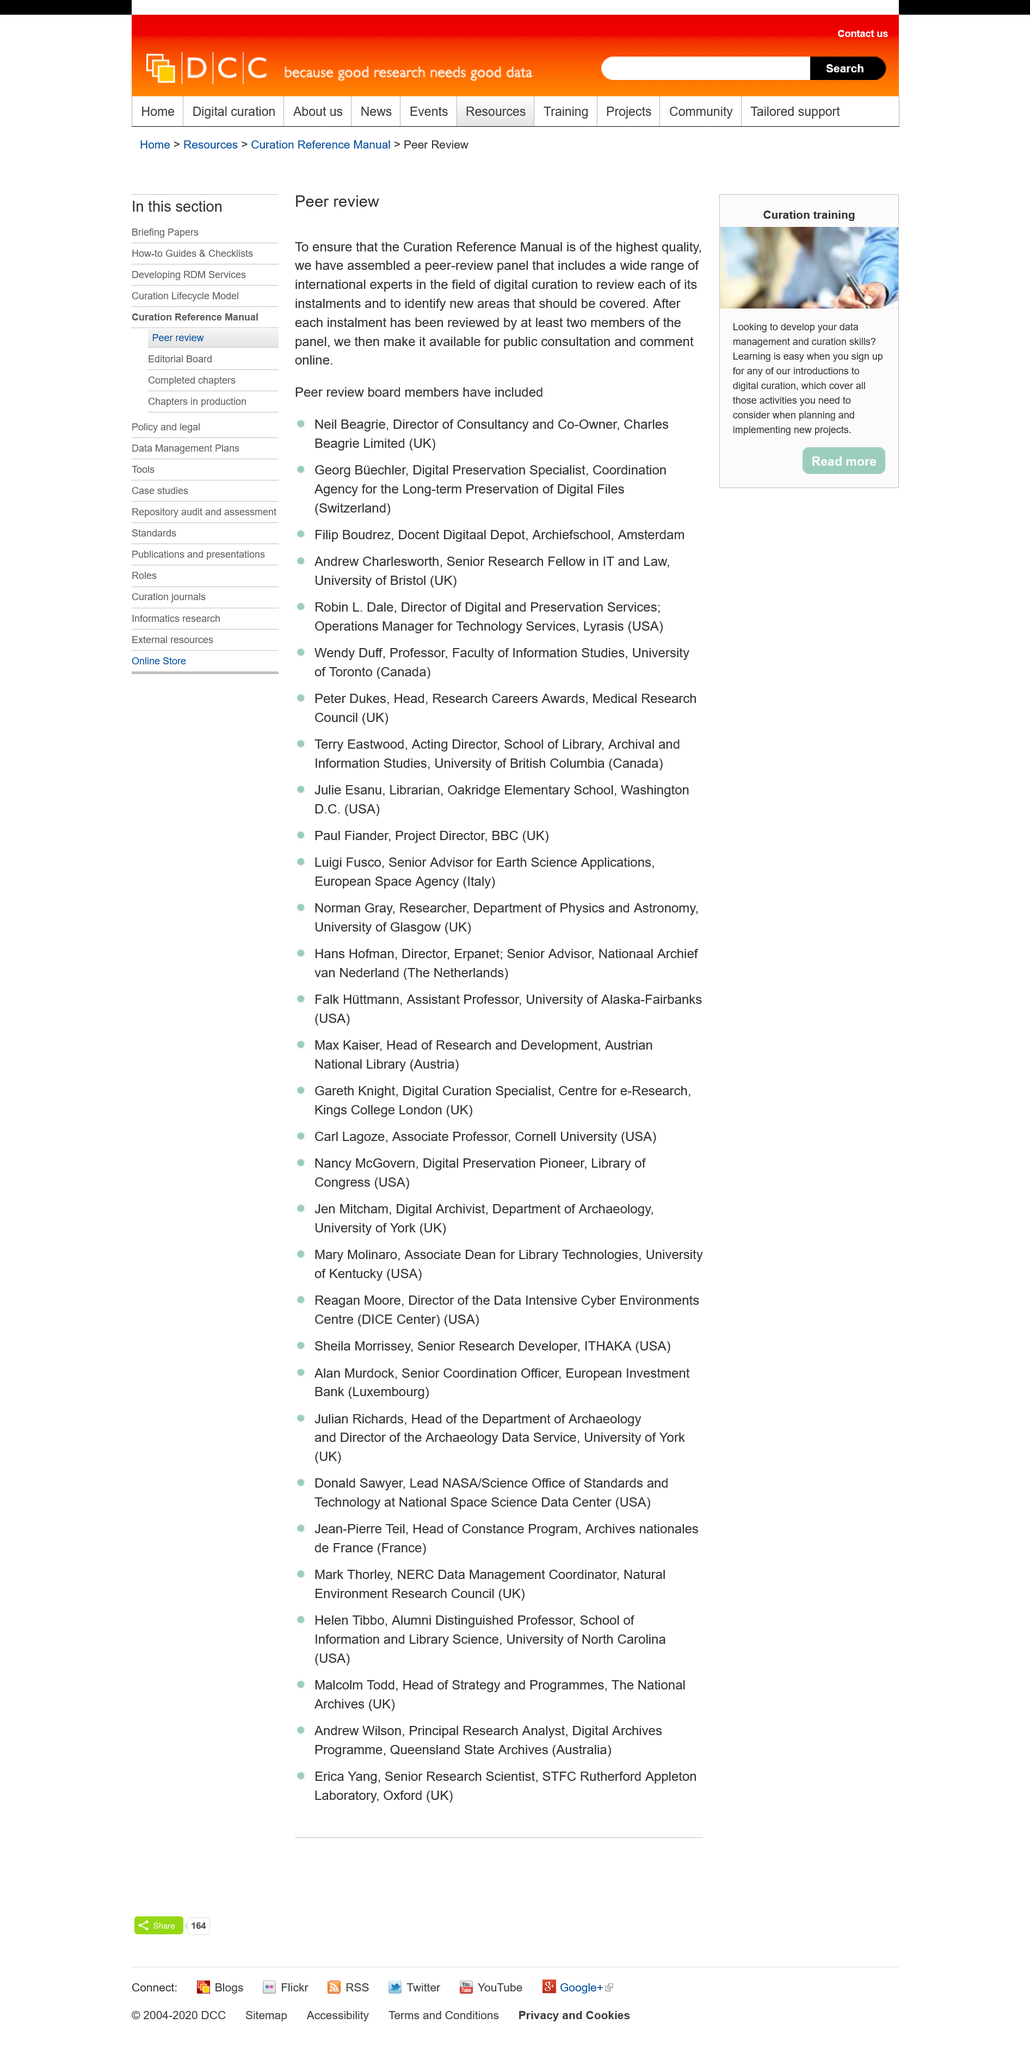Indicate a few pertinent items in this graphic. The main tasks of international experts are to review each installment and identify new areas that should be covered in order to enhance the quality of the educational program. After it has been reviewed by at least two members of the panel, the installments will be available to the public. The Curation Reference Manual was subjected to a peer-review panel method to ensure its highest quality. 